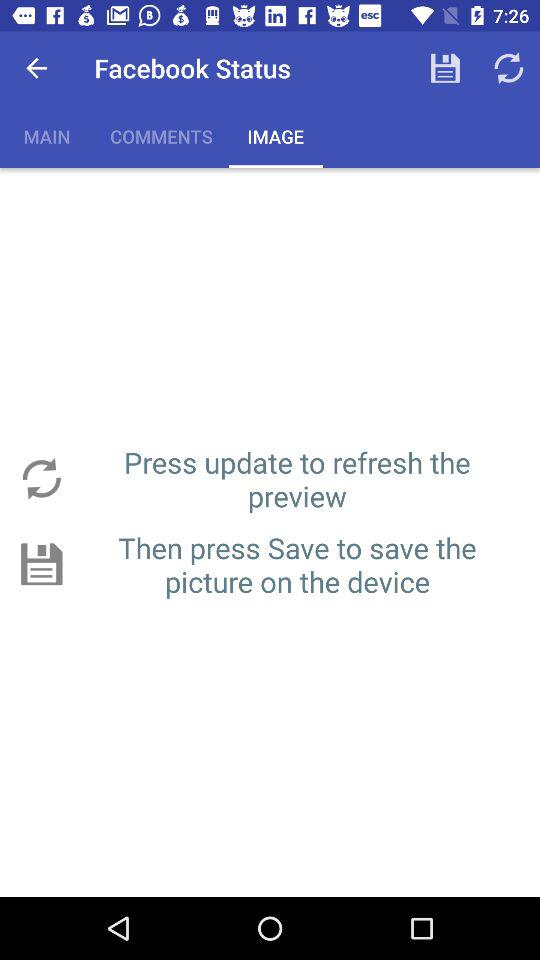What's the selected option in "Facebook Status"? The selected option is "IMAGES". 